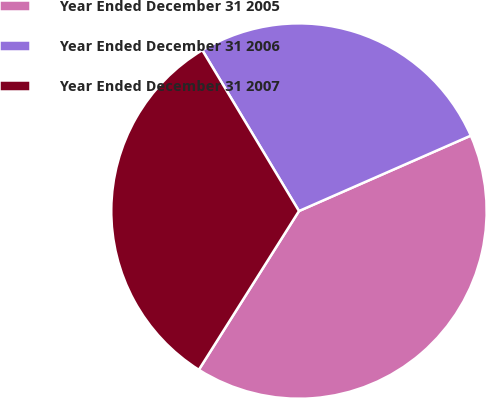Convert chart. <chart><loc_0><loc_0><loc_500><loc_500><pie_chart><fcel>Year Ended December 31 2005<fcel>Year Ended December 31 2006<fcel>Year Ended December 31 2007<nl><fcel>40.54%<fcel>27.03%<fcel>32.43%<nl></chart> 